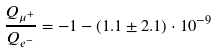<formula> <loc_0><loc_0><loc_500><loc_500>\frac { Q _ { \mu ^ { + } } } { Q _ { e ^ { - } } } = - 1 - ( 1 . 1 \pm 2 . 1 ) \cdot 1 0 ^ { - 9 }</formula> 